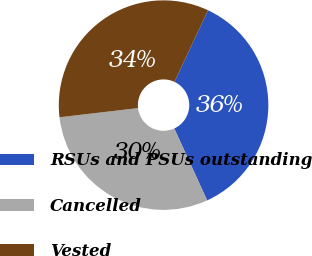<chart> <loc_0><loc_0><loc_500><loc_500><pie_chart><fcel>RSUs and PSUs outstanding<fcel>Cancelled<fcel>Vested<nl><fcel>36.2%<fcel>29.97%<fcel>33.83%<nl></chart> 